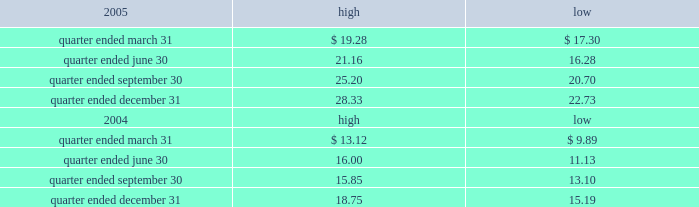Part ii item 5 .
Market for registrant 2019s common equity , related stockholder matters and issuer purchases of equity securities the table presents reported quarterly high and low per share sale prices of our class a common stock on the new york stock exchange ( nyse ) for the years 2005 and 2004. .
On march 9 , 2006 , the closing price of our class a common stock was $ 29.83 per share as reported on the nyse .
As of march 9 , 2006 , we had 419677495 outstanding shares of class a common stock and 687 registered holders .
In february 2004 , all outstanding shares of our class b common stock were converted into shares of our class a common stock on a one-for-one basis pursuant to the occurrence of the 201cdodge conversion event 201d as defined in our charter .
Also in february 2004 , all outstanding shares of class c common stock were converted into shares of class a common stock on a one-for-one basis .
In august 2005 , we amended and restated our charter to , among other things , eliminate our class b common stock and class c common stock .
The information under 201csecurities authorized for issuance under equity compensation plans 201d from the definitive proxy statement is hereby incorporated by reference into item 12 of this annual report .
Dividends we have never paid a dividend on any class of our common stock .
We anticipate that we may retain future earnings , if any , to fund the development and growth of our business .
The indentures governing our 7.50% ( 7.50 % ) senior notes due 2012 ( 7.50% ( 7.50 % ) notes ) and our 7.125% ( 7.125 % ) senior notes due 2012 ( 7.125% ( 7.125 % ) notes ) may prohibit us from paying dividends to our stockholders unless we satisfy certain financial covenants .
Our credit facilities and the indentures governing the terms of our debt securities contain covenants that may restrict the ability of our subsidiaries from making to us any direct or indirect distribution , dividend or other payment on account of their limited liability company interests , partnership interests , capital stock or other equity interests .
Under our credit facilities , the borrower subsidiaries may pay cash dividends or make other distributions to us in accordance with the applicable credit facility only if no default exists or would be created thereby .
The indenture governing the terms of the ati 7.25% ( 7.25 % ) senior subordinated notes due 2011 ( ati 7.25% ( 7.25 % ) notes ) prohibit ati and certain of our other subsidiaries that have guaranteed those notes ( sister guarantors ) from paying dividends and making other payments or distributions to us unless certain financial covenants are satisfied .
The indentures governing the terms of our 7.50% ( 7.50 % ) notes and 7.125% ( 7.125 % ) notes also contain certain restrictive covenants , which prohibit the restricted subsidiaries under these indentures from paying dividends and making other payments or distributions to us unless certain financial covenants are satisfied .
For more information about the restrictions under our credit facilities and our notes indentures , see note 7 to our consolidated financial statements included in this annual report and the section entitled 201cmanagement 2019s .
What is the growth rate in the common stock price from the highest price during quarter ended december 31 of 2005 to the highest price during quarter ended december 31 of 2006? 
Computations: ((28.33 - 18.75) / 18.75)
Answer: 0.51093. 